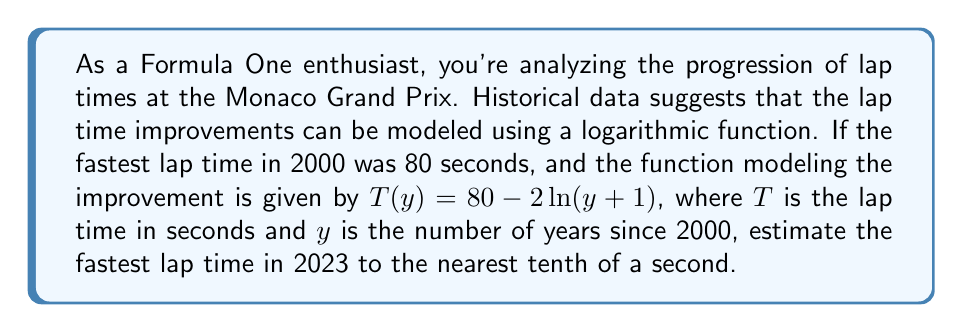Show me your answer to this math problem. To solve this problem, we need to follow these steps:

1) We're given the function $T(y) = 80 - 2\ln(y+1)$, where:
   - $T$ is the lap time in seconds
   - $y$ is the number of years since 2000
   - $\ln$ is the natural logarithm

2) We need to find $T(23)$, as 2023 is 23 years after 2000.

3) Let's substitute $y = 23$ into the function:

   $$T(23) = 80 - 2\ln(23+1)$$
   $$T(23) = 80 - 2\ln(24)$$

4) Now, we need to calculate this:

   $$T(23) = 80 - 2 \cdot 3.17805...$$
   $$T(23) = 80 - 6.35610...$$
   $$T(23) = 73.64389...$$

5) Rounding to the nearest tenth of a second:

   $$T(23) \approx 73.6 \text{ seconds}$$

Therefore, the estimated fastest lap time in 2023 is approximately 73.6 seconds.
Answer: 73.6 seconds 